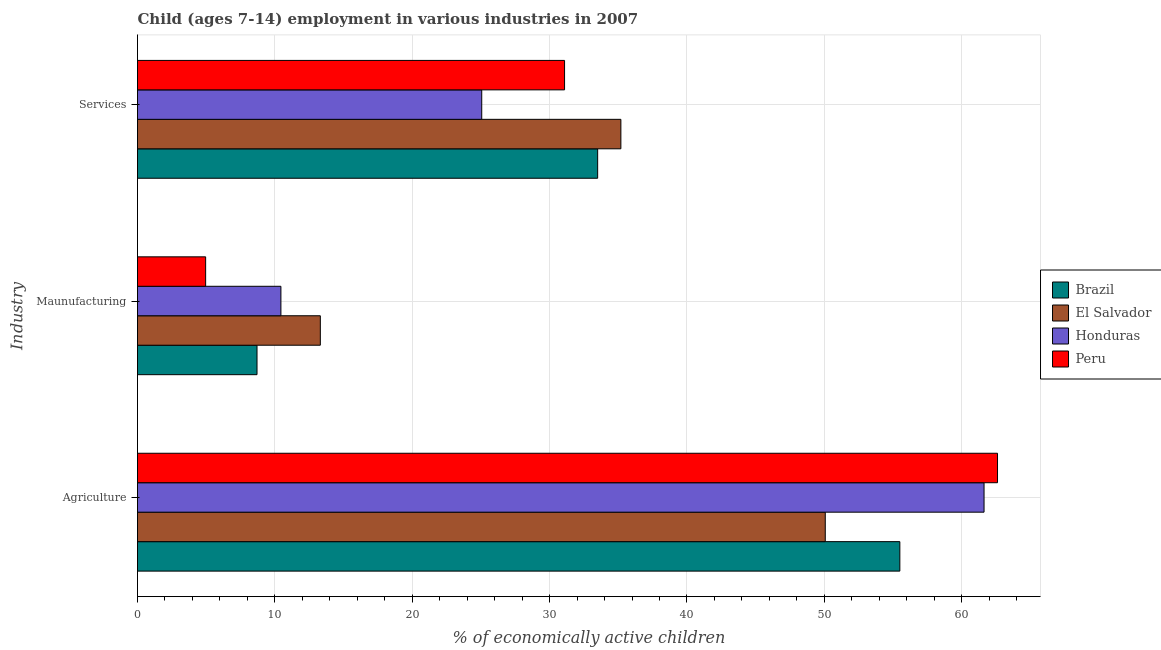How many different coloured bars are there?
Ensure brevity in your answer.  4. How many groups of bars are there?
Provide a short and direct response. 3. Are the number of bars per tick equal to the number of legend labels?
Make the answer very short. Yes. What is the label of the 1st group of bars from the top?
Your answer should be very brief. Services. What is the percentage of economically active children in manufacturing in El Salvador?
Your response must be concise. 13.31. Across all countries, what is the maximum percentage of economically active children in agriculture?
Your answer should be very brief. 62.61. Across all countries, what is the minimum percentage of economically active children in services?
Make the answer very short. 25.06. In which country was the percentage of economically active children in manufacturing minimum?
Your answer should be very brief. Peru. What is the total percentage of economically active children in manufacturing in the graph?
Your response must be concise. 37.41. What is the difference between the percentage of economically active children in manufacturing in Honduras and that in El Salvador?
Ensure brevity in your answer.  -2.87. What is the difference between the percentage of economically active children in services in El Salvador and the percentage of economically active children in manufacturing in Brazil?
Ensure brevity in your answer.  26.49. What is the average percentage of economically active children in services per country?
Offer a very short reply. 31.21. What is the difference between the percentage of economically active children in manufacturing and percentage of economically active children in services in Brazil?
Make the answer very short. -24.8. In how many countries, is the percentage of economically active children in services greater than 24 %?
Your answer should be compact. 4. What is the ratio of the percentage of economically active children in services in El Salvador to that in Peru?
Your answer should be very brief. 1.13. Is the percentage of economically active children in agriculture in Brazil less than that in Peru?
Ensure brevity in your answer.  Yes. Is the difference between the percentage of economically active children in services in El Salvador and Brazil greater than the difference between the percentage of economically active children in manufacturing in El Salvador and Brazil?
Your response must be concise. No. What is the difference between the highest and the second highest percentage of economically active children in agriculture?
Ensure brevity in your answer.  0.98. What is the difference between the highest and the lowest percentage of economically active children in services?
Your response must be concise. 10.13. In how many countries, is the percentage of economically active children in agriculture greater than the average percentage of economically active children in agriculture taken over all countries?
Your answer should be compact. 2. What does the 1st bar from the top in Agriculture represents?
Your answer should be very brief. Peru. Is it the case that in every country, the sum of the percentage of economically active children in agriculture and percentage of economically active children in manufacturing is greater than the percentage of economically active children in services?
Offer a very short reply. Yes. Are the values on the major ticks of X-axis written in scientific E-notation?
Ensure brevity in your answer.  No. How are the legend labels stacked?
Make the answer very short. Vertical. What is the title of the graph?
Ensure brevity in your answer.  Child (ages 7-14) employment in various industries in 2007. What is the label or title of the X-axis?
Your answer should be compact. % of economically active children. What is the label or title of the Y-axis?
Provide a short and direct response. Industry. What is the % of economically active children of Brazil in Agriculture?
Offer a very short reply. 55.5. What is the % of economically active children of El Salvador in Agriculture?
Your response must be concise. 50.07. What is the % of economically active children in Honduras in Agriculture?
Provide a succinct answer. 61.63. What is the % of economically active children in Peru in Agriculture?
Give a very brief answer. 62.61. What is the % of economically active children in El Salvador in Maunufacturing?
Your answer should be compact. 13.31. What is the % of economically active children of Honduras in Maunufacturing?
Provide a succinct answer. 10.44. What is the % of economically active children of Peru in Maunufacturing?
Offer a terse response. 4.96. What is the % of economically active children of Brazil in Services?
Your answer should be very brief. 33.5. What is the % of economically active children of El Salvador in Services?
Make the answer very short. 35.19. What is the % of economically active children of Honduras in Services?
Your answer should be compact. 25.06. What is the % of economically active children in Peru in Services?
Your answer should be very brief. 31.09. Across all Industry, what is the maximum % of economically active children of Brazil?
Your answer should be very brief. 55.5. Across all Industry, what is the maximum % of economically active children of El Salvador?
Offer a very short reply. 50.07. Across all Industry, what is the maximum % of economically active children in Honduras?
Give a very brief answer. 61.63. Across all Industry, what is the maximum % of economically active children of Peru?
Your response must be concise. 62.61. Across all Industry, what is the minimum % of economically active children of El Salvador?
Provide a succinct answer. 13.31. Across all Industry, what is the minimum % of economically active children of Honduras?
Keep it short and to the point. 10.44. Across all Industry, what is the minimum % of economically active children of Peru?
Your response must be concise. 4.96. What is the total % of economically active children of Brazil in the graph?
Provide a short and direct response. 97.7. What is the total % of economically active children in El Salvador in the graph?
Your answer should be very brief. 98.57. What is the total % of economically active children in Honduras in the graph?
Your answer should be very brief. 97.13. What is the total % of economically active children of Peru in the graph?
Your answer should be compact. 98.66. What is the difference between the % of economically active children of Brazil in Agriculture and that in Maunufacturing?
Ensure brevity in your answer.  46.8. What is the difference between the % of economically active children in El Salvador in Agriculture and that in Maunufacturing?
Offer a terse response. 36.76. What is the difference between the % of economically active children in Honduras in Agriculture and that in Maunufacturing?
Offer a very short reply. 51.19. What is the difference between the % of economically active children of Peru in Agriculture and that in Maunufacturing?
Provide a short and direct response. 57.65. What is the difference between the % of economically active children in El Salvador in Agriculture and that in Services?
Offer a terse response. 14.88. What is the difference between the % of economically active children of Honduras in Agriculture and that in Services?
Offer a very short reply. 36.57. What is the difference between the % of economically active children of Peru in Agriculture and that in Services?
Your response must be concise. 31.52. What is the difference between the % of economically active children of Brazil in Maunufacturing and that in Services?
Give a very brief answer. -24.8. What is the difference between the % of economically active children in El Salvador in Maunufacturing and that in Services?
Make the answer very short. -21.88. What is the difference between the % of economically active children in Honduras in Maunufacturing and that in Services?
Offer a terse response. -14.62. What is the difference between the % of economically active children in Peru in Maunufacturing and that in Services?
Offer a terse response. -26.13. What is the difference between the % of economically active children of Brazil in Agriculture and the % of economically active children of El Salvador in Maunufacturing?
Provide a short and direct response. 42.19. What is the difference between the % of economically active children in Brazil in Agriculture and the % of economically active children in Honduras in Maunufacturing?
Make the answer very short. 45.06. What is the difference between the % of economically active children of Brazil in Agriculture and the % of economically active children of Peru in Maunufacturing?
Ensure brevity in your answer.  50.54. What is the difference between the % of economically active children of El Salvador in Agriculture and the % of economically active children of Honduras in Maunufacturing?
Ensure brevity in your answer.  39.63. What is the difference between the % of economically active children in El Salvador in Agriculture and the % of economically active children in Peru in Maunufacturing?
Offer a very short reply. 45.11. What is the difference between the % of economically active children in Honduras in Agriculture and the % of economically active children in Peru in Maunufacturing?
Give a very brief answer. 56.67. What is the difference between the % of economically active children in Brazil in Agriculture and the % of economically active children in El Salvador in Services?
Make the answer very short. 20.31. What is the difference between the % of economically active children in Brazil in Agriculture and the % of economically active children in Honduras in Services?
Ensure brevity in your answer.  30.44. What is the difference between the % of economically active children in Brazil in Agriculture and the % of economically active children in Peru in Services?
Your response must be concise. 24.41. What is the difference between the % of economically active children of El Salvador in Agriculture and the % of economically active children of Honduras in Services?
Make the answer very short. 25.01. What is the difference between the % of economically active children of El Salvador in Agriculture and the % of economically active children of Peru in Services?
Your answer should be very brief. 18.98. What is the difference between the % of economically active children in Honduras in Agriculture and the % of economically active children in Peru in Services?
Make the answer very short. 30.54. What is the difference between the % of economically active children of Brazil in Maunufacturing and the % of economically active children of El Salvador in Services?
Your answer should be compact. -26.49. What is the difference between the % of economically active children in Brazil in Maunufacturing and the % of economically active children in Honduras in Services?
Provide a succinct answer. -16.36. What is the difference between the % of economically active children in Brazil in Maunufacturing and the % of economically active children in Peru in Services?
Your answer should be very brief. -22.39. What is the difference between the % of economically active children in El Salvador in Maunufacturing and the % of economically active children in Honduras in Services?
Your answer should be compact. -11.75. What is the difference between the % of economically active children in El Salvador in Maunufacturing and the % of economically active children in Peru in Services?
Provide a short and direct response. -17.78. What is the difference between the % of economically active children in Honduras in Maunufacturing and the % of economically active children in Peru in Services?
Provide a succinct answer. -20.65. What is the average % of economically active children in Brazil per Industry?
Ensure brevity in your answer.  32.57. What is the average % of economically active children of El Salvador per Industry?
Your answer should be compact. 32.86. What is the average % of economically active children in Honduras per Industry?
Make the answer very short. 32.38. What is the average % of economically active children of Peru per Industry?
Offer a very short reply. 32.89. What is the difference between the % of economically active children of Brazil and % of economically active children of El Salvador in Agriculture?
Give a very brief answer. 5.43. What is the difference between the % of economically active children of Brazil and % of economically active children of Honduras in Agriculture?
Your answer should be very brief. -6.13. What is the difference between the % of economically active children in Brazil and % of economically active children in Peru in Agriculture?
Your response must be concise. -7.11. What is the difference between the % of economically active children of El Salvador and % of economically active children of Honduras in Agriculture?
Provide a short and direct response. -11.56. What is the difference between the % of economically active children of El Salvador and % of economically active children of Peru in Agriculture?
Your answer should be compact. -12.54. What is the difference between the % of economically active children of Honduras and % of economically active children of Peru in Agriculture?
Keep it short and to the point. -0.98. What is the difference between the % of economically active children of Brazil and % of economically active children of El Salvador in Maunufacturing?
Keep it short and to the point. -4.61. What is the difference between the % of economically active children of Brazil and % of economically active children of Honduras in Maunufacturing?
Ensure brevity in your answer.  -1.74. What is the difference between the % of economically active children in Brazil and % of economically active children in Peru in Maunufacturing?
Keep it short and to the point. 3.74. What is the difference between the % of economically active children in El Salvador and % of economically active children in Honduras in Maunufacturing?
Provide a short and direct response. 2.87. What is the difference between the % of economically active children of El Salvador and % of economically active children of Peru in Maunufacturing?
Provide a succinct answer. 8.35. What is the difference between the % of economically active children of Honduras and % of economically active children of Peru in Maunufacturing?
Provide a succinct answer. 5.48. What is the difference between the % of economically active children of Brazil and % of economically active children of El Salvador in Services?
Your response must be concise. -1.69. What is the difference between the % of economically active children of Brazil and % of economically active children of Honduras in Services?
Ensure brevity in your answer.  8.44. What is the difference between the % of economically active children of Brazil and % of economically active children of Peru in Services?
Give a very brief answer. 2.41. What is the difference between the % of economically active children in El Salvador and % of economically active children in Honduras in Services?
Your response must be concise. 10.13. What is the difference between the % of economically active children of Honduras and % of economically active children of Peru in Services?
Provide a short and direct response. -6.03. What is the ratio of the % of economically active children of Brazil in Agriculture to that in Maunufacturing?
Ensure brevity in your answer.  6.38. What is the ratio of the % of economically active children in El Salvador in Agriculture to that in Maunufacturing?
Make the answer very short. 3.76. What is the ratio of the % of economically active children in Honduras in Agriculture to that in Maunufacturing?
Your answer should be very brief. 5.9. What is the ratio of the % of economically active children in Peru in Agriculture to that in Maunufacturing?
Provide a succinct answer. 12.62. What is the ratio of the % of economically active children in Brazil in Agriculture to that in Services?
Offer a terse response. 1.66. What is the ratio of the % of economically active children in El Salvador in Agriculture to that in Services?
Provide a succinct answer. 1.42. What is the ratio of the % of economically active children in Honduras in Agriculture to that in Services?
Provide a succinct answer. 2.46. What is the ratio of the % of economically active children in Peru in Agriculture to that in Services?
Make the answer very short. 2.01. What is the ratio of the % of economically active children in Brazil in Maunufacturing to that in Services?
Keep it short and to the point. 0.26. What is the ratio of the % of economically active children in El Salvador in Maunufacturing to that in Services?
Your response must be concise. 0.38. What is the ratio of the % of economically active children in Honduras in Maunufacturing to that in Services?
Offer a terse response. 0.42. What is the ratio of the % of economically active children in Peru in Maunufacturing to that in Services?
Provide a succinct answer. 0.16. What is the difference between the highest and the second highest % of economically active children in Brazil?
Give a very brief answer. 22. What is the difference between the highest and the second highest % of economically active children of El Salvador?
Ensure brevity in your answer.  14.88. What is the difference between the highest and the second highest % of economically active children of Honduras?
Your answer should be very brief. 36.57. What is the difference between the highest and the second highest % of economically active children in Peru?
Offer a terse response. 31.52. What is the difference between the highest and the lowest % of economically active children in Brazil?
Your answer should be compact. 46.8. What is the difference between the highest and the lowest % of economically active children in El Salvador?
Your answer should be compact. 36.76. What is the difference between the highest and the lowest % of economically active children of Honduras?
Your response must be concise. 51.19. What is the difference between the highest and the lowest % of economically active children in Peru?
Your response must be concise. 57.65. 